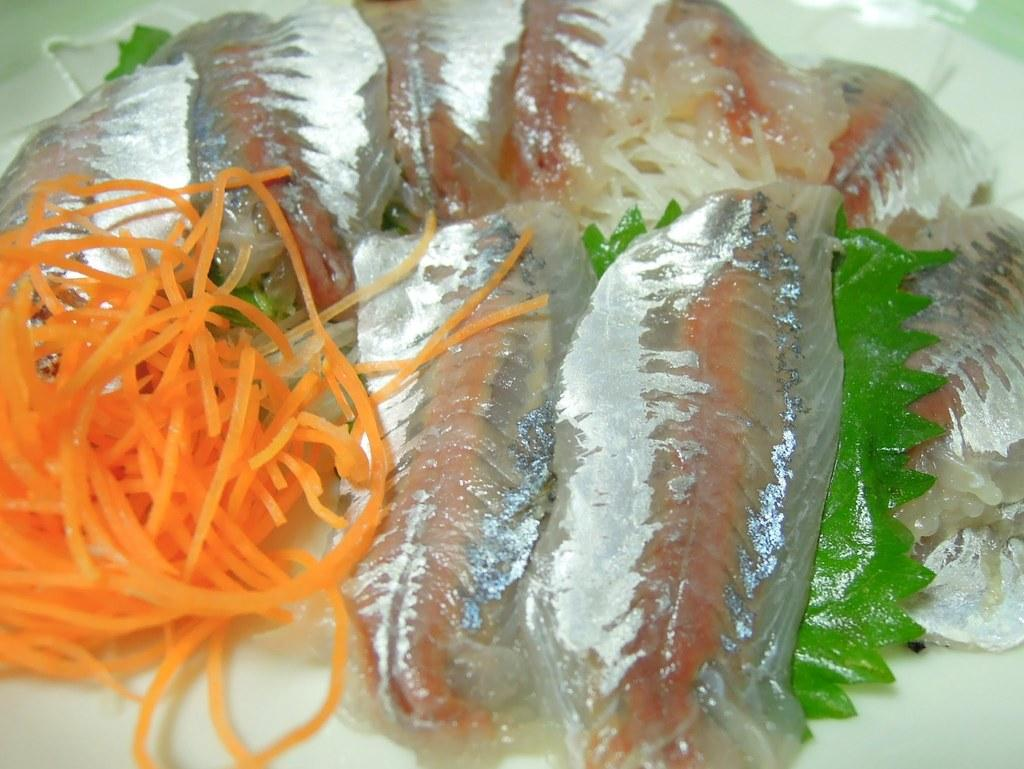What object is present in the image that typically holds food? There is a plate in the image. What is on the plate? The plate contains food. What time of day is the creature shown enjoying the food on the plate in the image? There is no creature present in the image, and the time of day is not mentioned or depicted. How many clocks are visible in the image? There are no clocks visible in the image. 